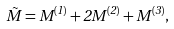Convert formula to latex. <formula><loc_0><loc_0><loc_500><loc_500>\tilde { M } = M ^ { ( 1 ) } + 2 M ^ { ( 2 ) } + M ^ { ( 3 ) } ,</formula> 